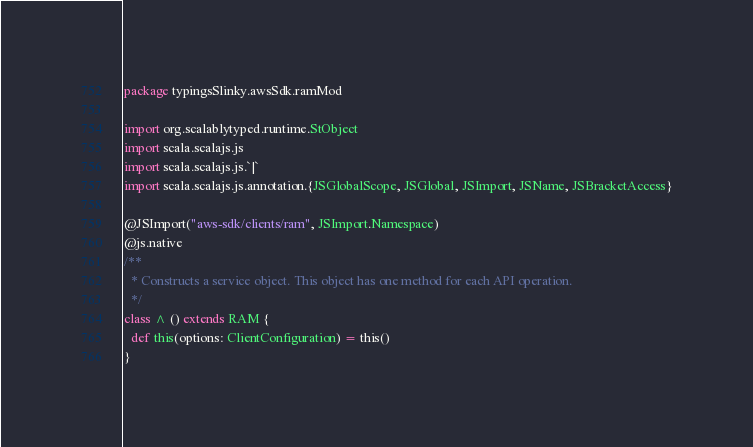<code> <loc_0><loc_0><loc_500><loc_500><_Scala_>package typingsSlinky.awsSdk.ramMod

import org.scalablytyped.runtime.StObject
import scala.scalajs.js
import scala.scalajs.js.`|`
import scala.scalajs.js.annotation.{JSGlobalScope, JSGlobal, JSImport, JSName, JSBracketAccess}

@JSImport("aws-sdk/clients/ram", JSImport.Namespace)
@js.native
/**
  * Constructs a service object. This object has one method for each API operation.
  */
class ^ () extends RAM {
  def this(options: ClientConfiguration) = this()
}
</code> 